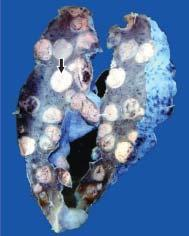re large parts of the lung parenchyma replaced by multiple, variable-sized, circumscribed nodular masses which are grey-white in colour?
Answer the question using a single word or phrase. Yes 